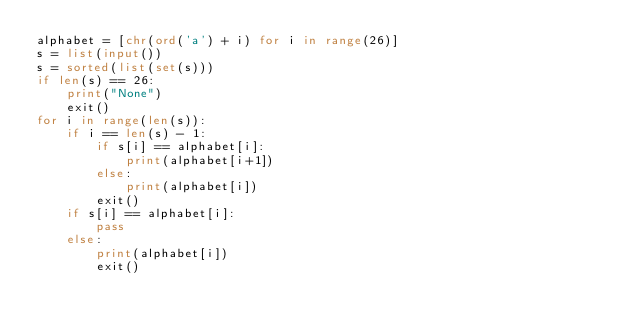<code> <loc_0><loc_0><loc_500><loc_500><_Python_>alphabet = [chr(ord('a') + i) for i in range(26)]
s = list(input())
s = sorted(list(set(s)))
if len(s) == 26:
    print("None")
    exit()
for i in range(len(s)):
    if i == len(s) - 1:
        if s[i] == alphabet[i]:
            print(alphabet[i+1])
        else:
            print(alphabet[i])
        exit()
    if s[i] == alphabet[i]:
        pass
    else:
        print(alphabet[i])
        exit()</code> 